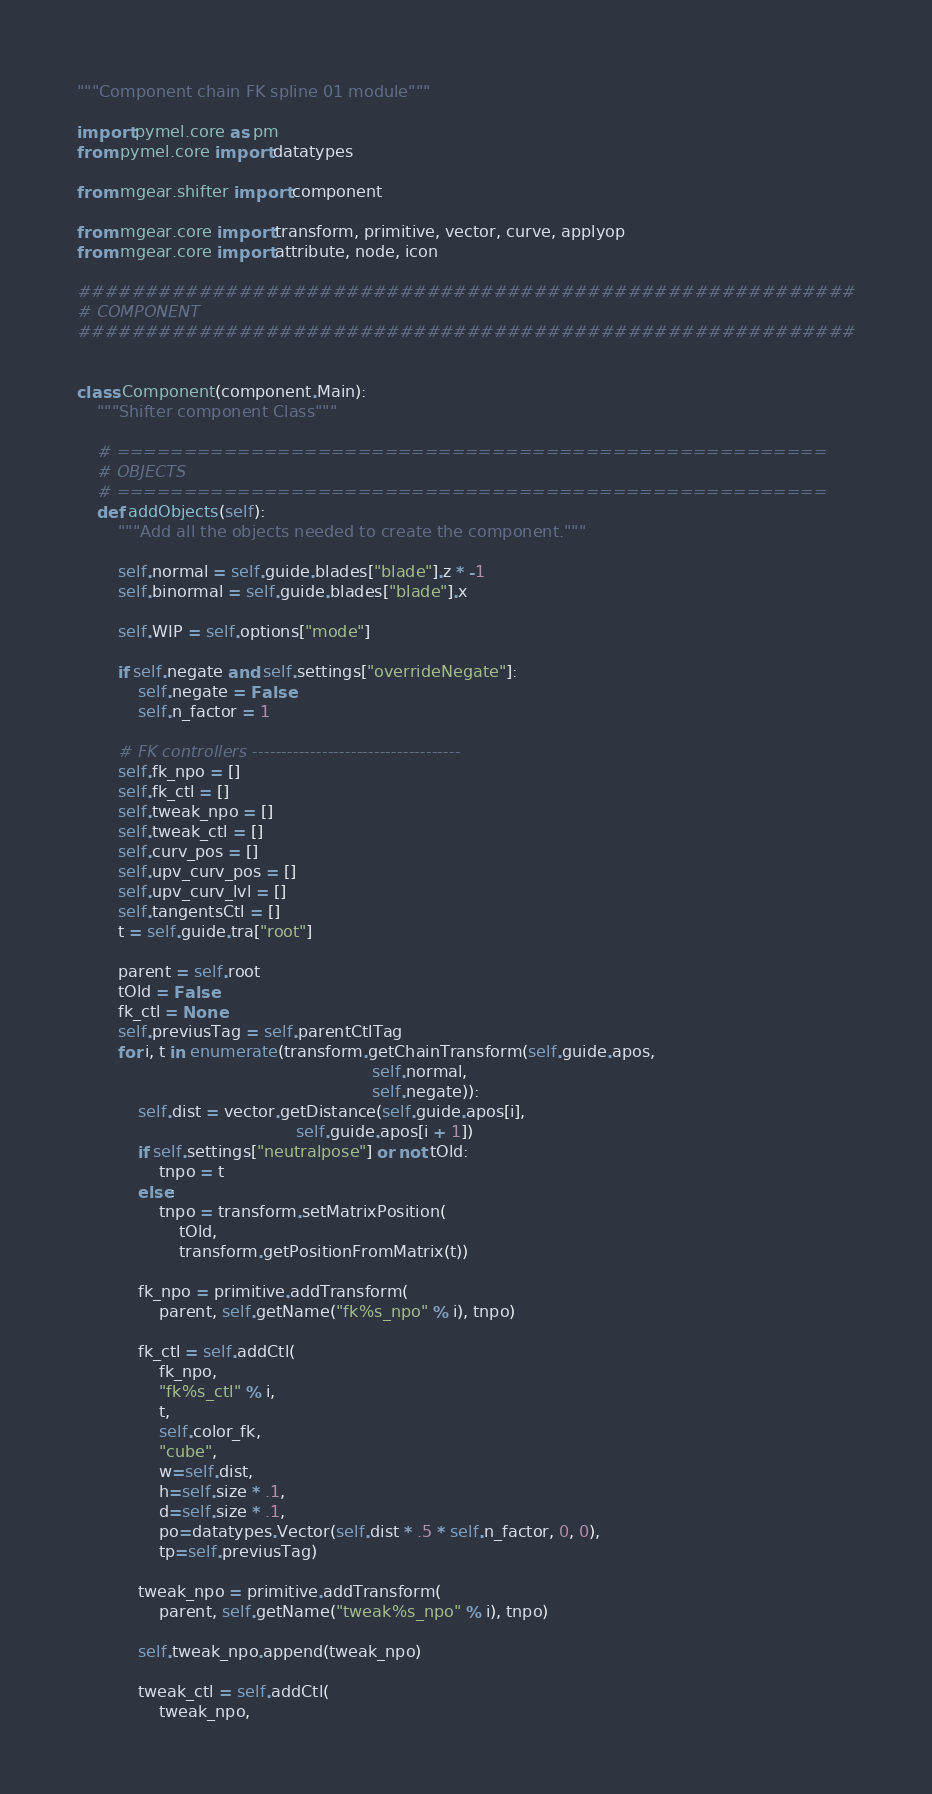<code> <loc_0><loc_0><loc_500><loc_500><_Python_>"""Component chain FK spline 01 module"""

import pymel.core as pm
from pymel.core import datatypes

from mgear.shifter import component

from mgear.core import transform, primitive, vector, curve, applyop
from mgear.core import attribute, node, icon

##########################################################
# COMPONENT
##########################################################


class Component(component.Main):
    """Shifter component Class"""

    # =====================================================
    # OBJECTS
    # =====================================================
    def addObjects(self):
        """Add all the objects needed to create the component."""

        self.normal = self.guide.blades["blade"].z * -1
        self.binormal = self.guide.blades["blade"].x

        self.WIP = self.options["mode"]

        if self.negate and self.settings["overrideNegate"]:
            self.negate = False
            self.n_factor = 1

        # FK controllers ------------------------------------
        self.fk_npo = []
        self.fk_ctl = []
        self.tweak_npo = []
        self.tweak_ctl = []
        self.curv_pos = []
        self.upv_curv_pos = []
        self.upv_curv_lvl = []
        self.tangentsCtl = []
        t = self.guide.tra["root"]

        parent = self.root
        tOld = False
        fk_ctl = None
        self.previusTag = self.parentCtlTag
        for i, t in enumerate(transform.getChainTransform(self.guide.apos,
                                                          self.normal,
                                                          self.negate)):
            self.dist = vector.getDistance(self.guide.apos[i],
                                           self.guide.apos[i + 1])
            if self.settings["neutralpose"] or not tOld:
                tnpo = t
            else:
                tnpo = transform.setMatrixPosition(
                    tOld,
                    transform.getPositionFromMatrix(t))

            fk_npo = primitive.addTransform(
                parent, self.getName("fk%s_npo" % i), tnpo)

            fk_ctl = self.addCtl(
                fk_npo,
                "fk%s_ctl" % i,
                t,
                self.color_fk,
                "cube",
                w=self.dist,
                h=self.size * .1,
                d=self.size * .1,
                po=datatypes.Vector(self.dist * .5 * self.n_factor, 0, 0),
                tp=self.previusTag)

            tweak_npo = primitive.addTransform(
                parent, self.getName("tweak%s_npo" % i), tnpo)

            self.tweak_npo.append(tweak_npo)

            tweak_ctl = self.addCtl(
                tweak_npo,</code> 